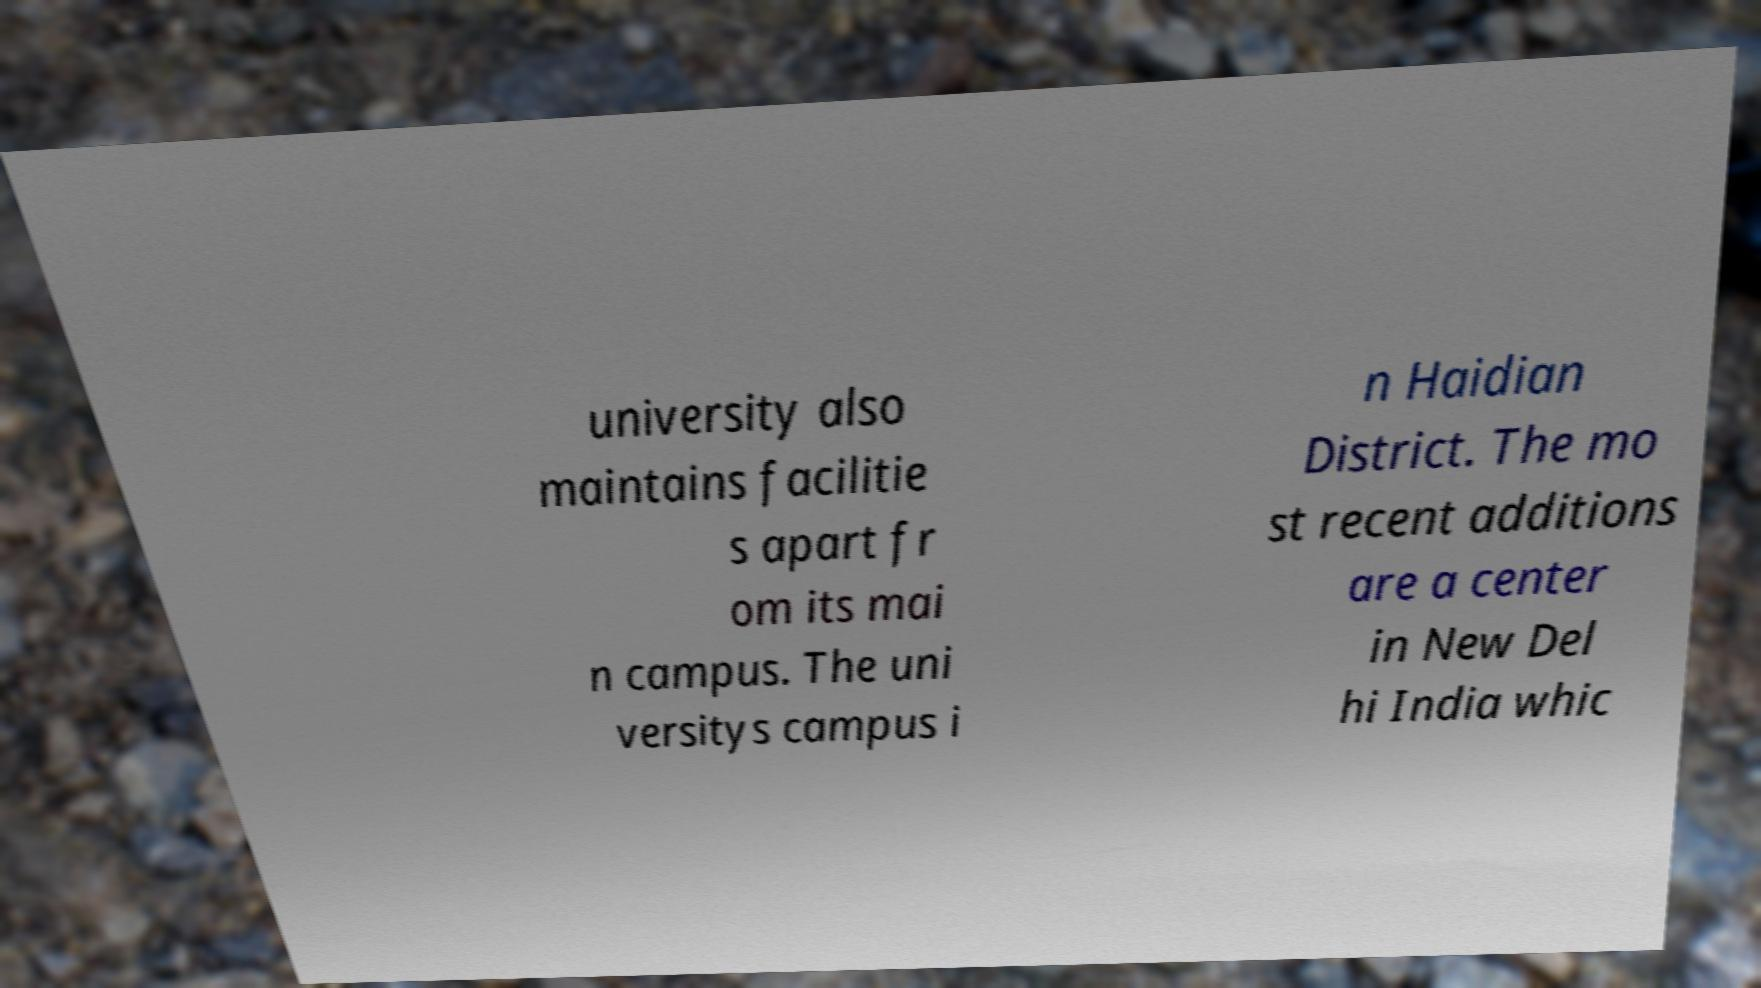Please identify and transcribe the text found in this image. university also maintains facilitie s apart fr om its mai n campus. The uni versitys campus i n Haidian District. The mo st recent additions are a center in New Del hi India whic 